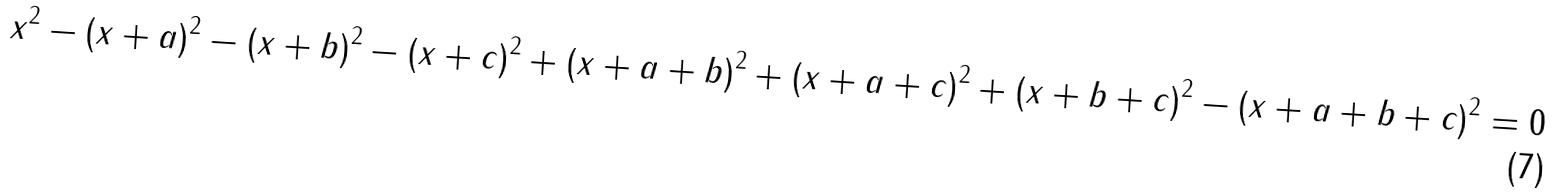<formula> <loc_0><loc_0><loc_500><loc_500>x ^ { 2 } - ( x + a ) ^ { 2 } - ( x + b ) ^ { 2 } - ( x + c ) ^ { 2 } + ( x + a + b ) ^ { 2 } + ( x + a + c ) ^ { 2 } + ( x + b + c ) ^ { 2 } - ( x + a + b + c ) ^ { 2 } = 0</formula> 